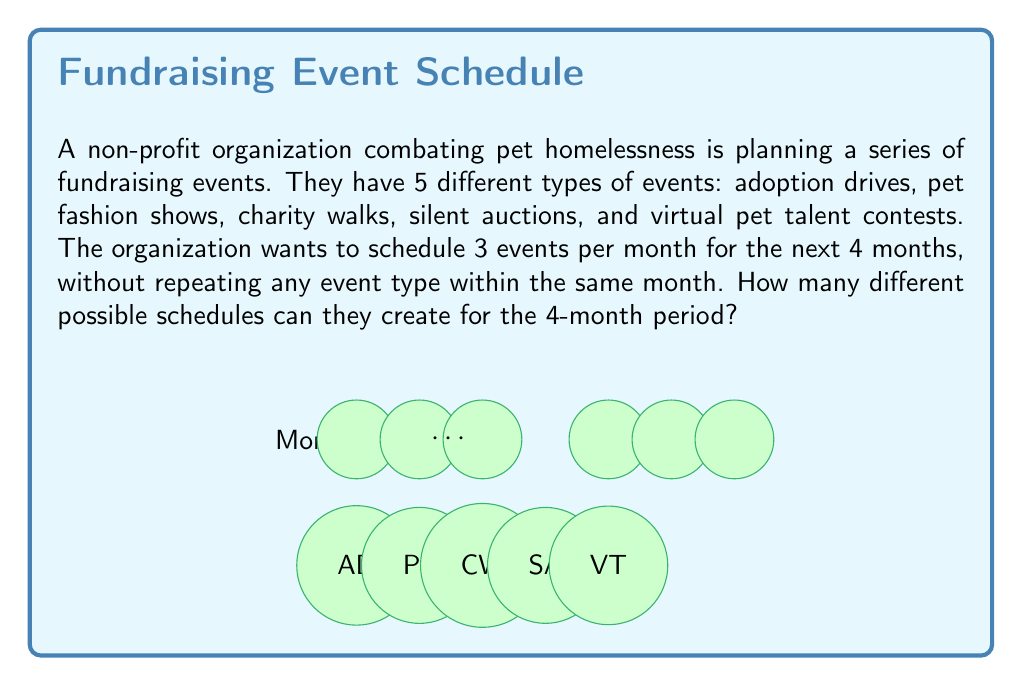Give your solution to this math problem. Let's approach this step-by-step:

1) For each month, we need to choose 3 events out of 5 without repetition. This is a combination problem.

2) The number of ways to choose 3 events out of 5 for a single month is:

   $$\binom{5}{3} = \frac{5!}{3!(5-3)!} = \frac{5 \cdot 4 \cdot 3}{3 \cdot 2 \cdot 1} = 10$$

3) Now, for each subsequent month, we make the same choice independently. This means we multiply the number of choices for each month.

4) Since we have 4 months, and each month has 10 possible combinations, the total number of possible schedules is:

   $$10 \cdot 10 \cdot 10 \cdot 10 = 10^4 = 10,000$$

5) We can also express this using the combination notation:

   $$\left(\binom{5}{3}\right)^4 = 10,000$$

Therefore, the non-profit organization can create 10,000 different possible schedules for the 4-month period.
Answer: $10,000$ 